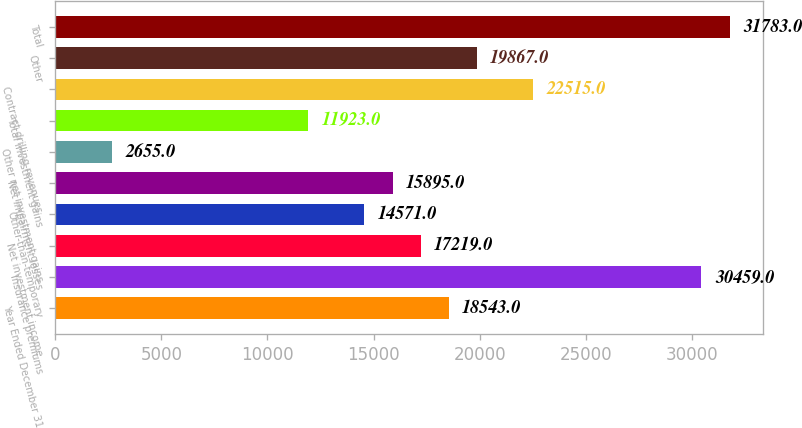<chart> <loc_0><loc_0><loc_500><loc_500><bar_chart><fcel>Year Ended December 31<fcel>Insurance premiums<fcel>Net investment income<fcel>Other-than-temporary<fcel>Net impairment losses<fcel>Other net investment gains<fcel>Total investment gains<fcel>Contract drilling revenues<fcel>Other<fcel>Total<nl><fcel>18543<fcel>30459<fcel>17219<fcel>14571<fcel>15895<fcel>2655<fcel>11923<fcel>22515<fcel>19867<fcel>31783<nl></chart> 